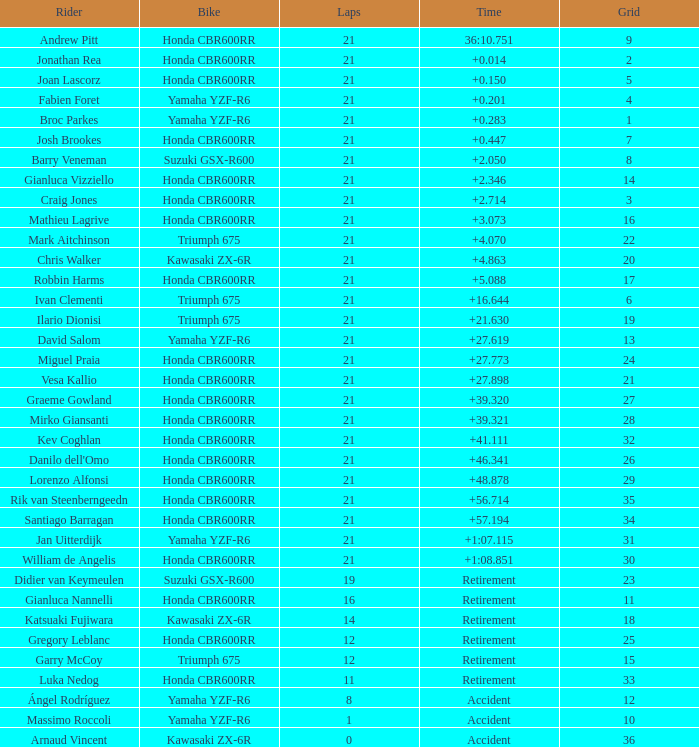What is the cumulative number of laps completed by the driver with a grid below 17 and a time of + None. 